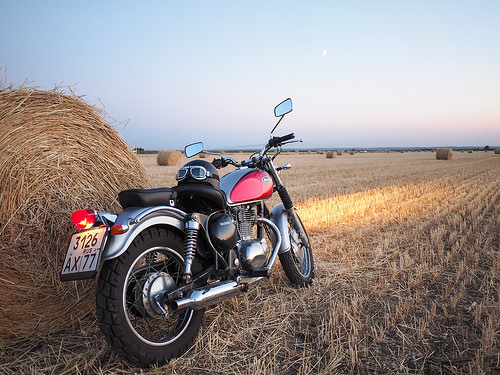<image>
Is the haystack to the right of the motorcycle? No. The haystack is not to the right of the motorcycle. The horizontal positioning shows a different relationship. 